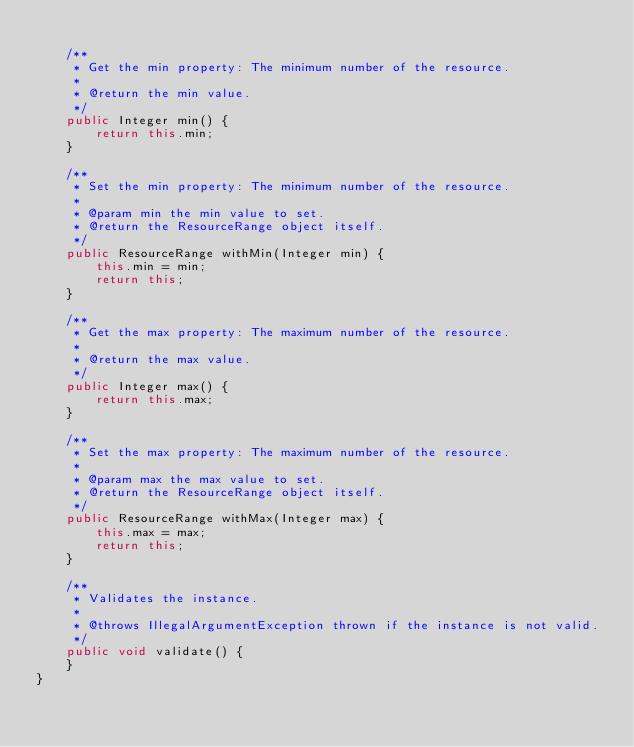Convert code to text. <code><loc_0><loc_0><loc_500><loc_500><_Java_>
    /**
     * Get the min property: The minimum number of the resource.
     *
     * @return the min value.
     */
    public Integer min() {
        return this.min;
    }

    /**
     * Set the min property: The minimum number of the resource.
     *
     * @param min the min value to set.
     * @return the ResourceRange object itself.
     */
    public ResourceRange withMin(Integer min) {
        this.min = min;
        return this;
    }

    /**
     * Get the max property: The maximum number of the resource.
     *
     * @return the max value.
     */
    public Integer max() {
        return this.max;
    }

    /**
     * Set the max property: The maximum number of the resource.
     *
     * @param max the max value to set.
     * @return the ResourceRange object itself.
     */
    public ResourceRange withMax(Integer max) {
        this.max = max;
        return this;
    }

    /**
     * Validates the instance.
     *
     * @throws IllegalArgumentException thrown if the instance is not valid.
     */
    public void validate() {
    }
}
</code> 